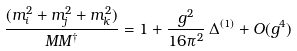Convert formula to latex. <formula><loc_0><loc_0><loc_500><loc_500>\frac { ( m _ { i } ^ { 2 } + m _ { j } ^ { 2 } + m _ { k } ^ { 2 } ) } { M M ^ { \dag } } = 1 + \frac { g ^ { 2 } } { 1 6 \pi ^ { 2 } } \, \Delta ^ { ( 1 ) } + O ( g ^ { 4 } )</formula> 